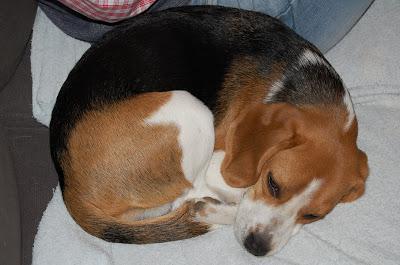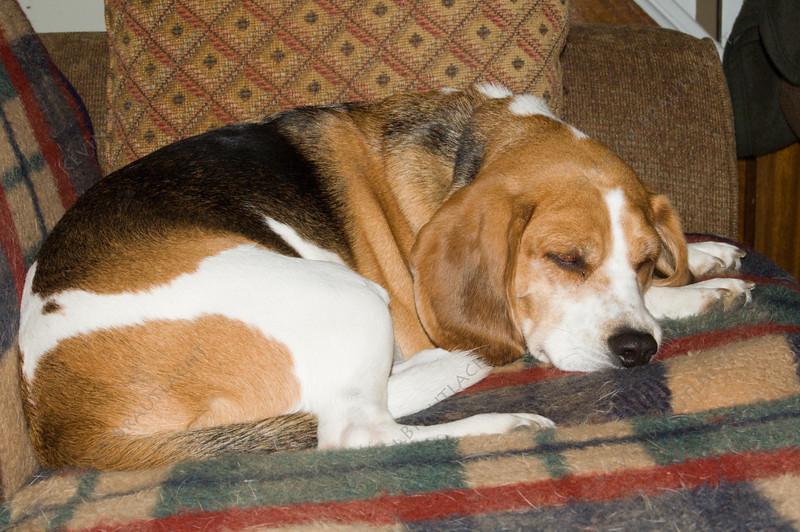The first image is the image on the left, the second image is the image on the right. Analyze the images presented: Is the assertion "At least one dog is curled up in a ball." valid? Answer yes or no. Yes. The first image is the image on the left, the second image is the image on the right. For the images displayed, is the sentence "The dogs are lying in the same direction." factually correct? Answer yes or no. Yes. 